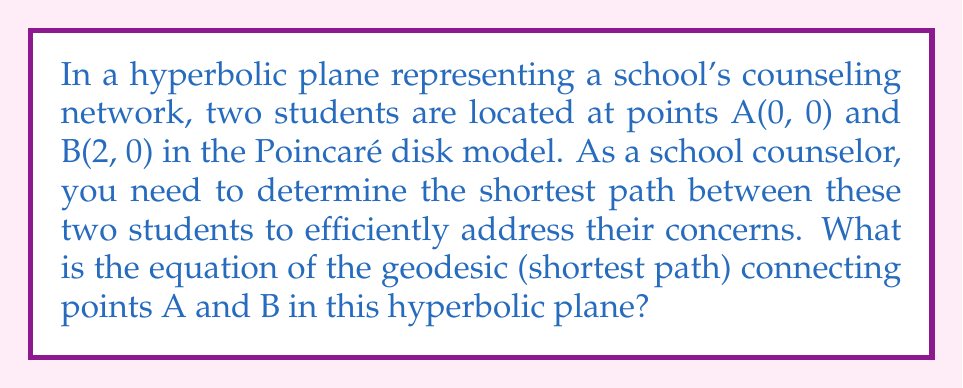Solve this math problem. To find the shortest path between two points on a hyperbolic plane using the Poincaré disk model, we follow these steps:

1. In the Poincaré disk model, geodesics (shortest paths) are represented by either:
   a) Arcs of circles that intersect the boundary of the disk at right angles
   b) Diameters of the disk

2. Since points A(0, 0) and B(2, 0) lie on the same diameter, the geodesic between them is a straight line segment.

3. The equation of a straight line passing through two points (x₁, y₁) and (x₂, y₂) is given by:

   $$ y - y_1 = m(x - x_1) $$

   where $m$ is the slope: $m = \frac{y_2 - y_1}{x_2 - x_1}$

4. In this case:
   - (x₁, y₁) = (0, 0)
   - (x₂, y₂) = (2, 0)

5. Calculate the slope:
   $$ m = \frac{0 - 0}{2 - 0} = 0 $$

6. Substitute into the line equation:
   $$ y - 0 = 0(x - 0) $$

7. Simplify:
   $$ y = 0 $$

This equation represents the x-axis, which is the diameter of the Poincaré disk passing through points A and B.

[asy]
unitsize(2cm);
draw(circle((0,0),1));
dot((0,0),red);
dot((0.8,0),red);
draw((0,0)--(0.8,0),blue);
label("A", (0,0), S);
label("B", (0.8,0), S);
[/asy]
Answer: $y = 0$ 